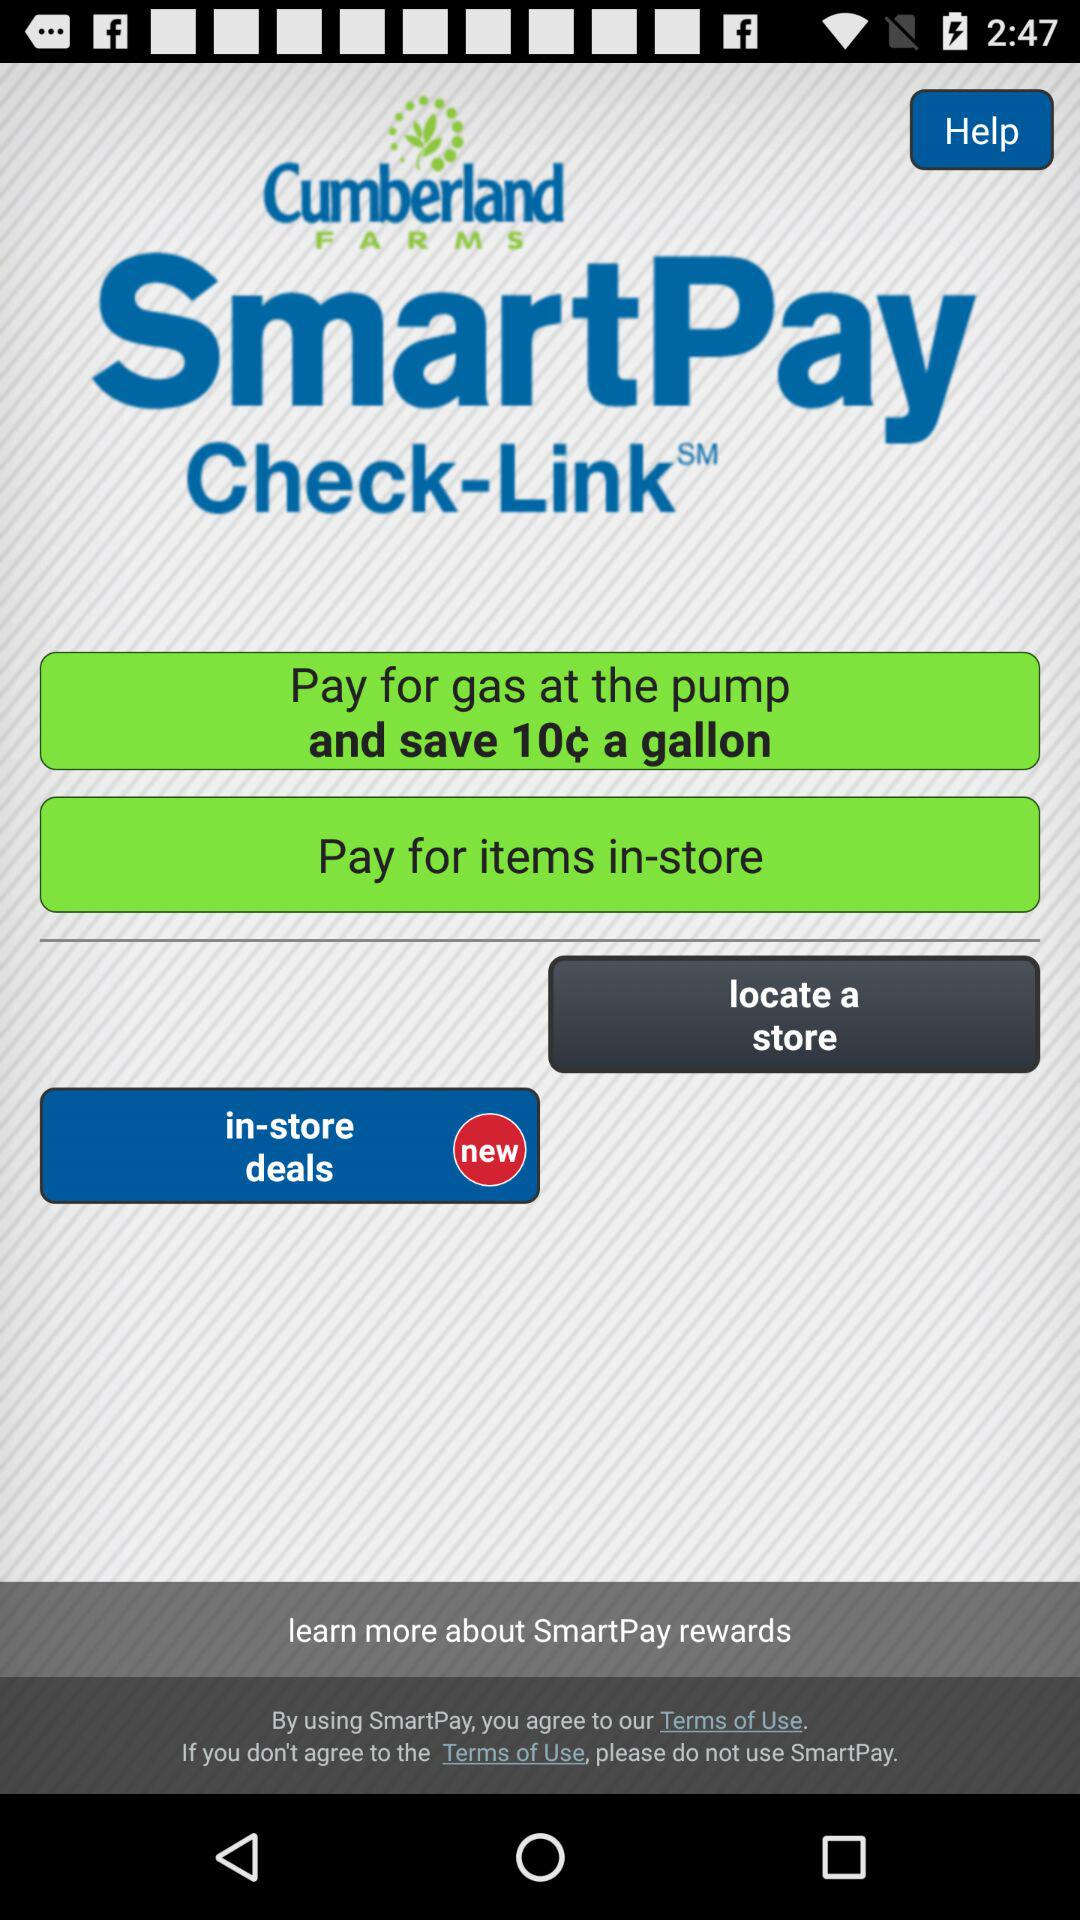What is the application name? The application name is "SmartPay". 